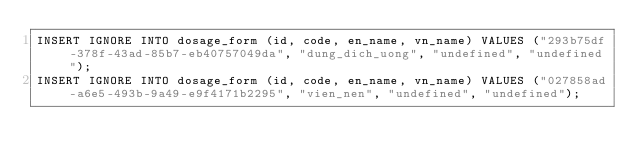<code> <loc_0><loc_0><loc_500><loc_500><_SQL_>INSERT IGNORE INTO dosage_form (id, code, en_name, vn_name) VALUES ("293b75df-378f-43ad-85b7-eb40757049da", "dung_dich_uong", "undefined", "undefined");
INSERT IGNORE INTO dosage_form (id, code, en_name, vn_name) VALUES ("027858ad-a6e5-493b-9a49-e9f4171b2295", "vien_nen", "undefined", "undefined");</code> 